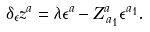Convert formula to latex. <formula><loc_0><loc_0><loc_500><loc_500>\delta _ { \epsilon } z ^ { a } = \lambda \epsilon ^ { a } - Z _ { \, a _ { 1 } } ^ { a } \epsilon ^ { a _ { 1 } } .</formula> 